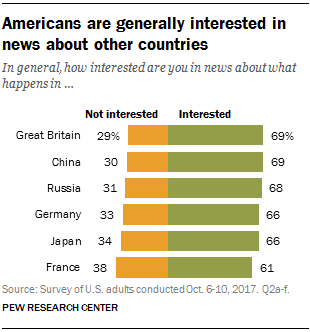Specify some key components in this picture. If the average data of Germany, Japan, and France is taken for two categories [35, 64], the result can be expected. According to the chart provided, data on study habits in Great Britain indicates that 29% of the population studied between 2000 and 2002, while 69% studied between 2010 and 2012. 